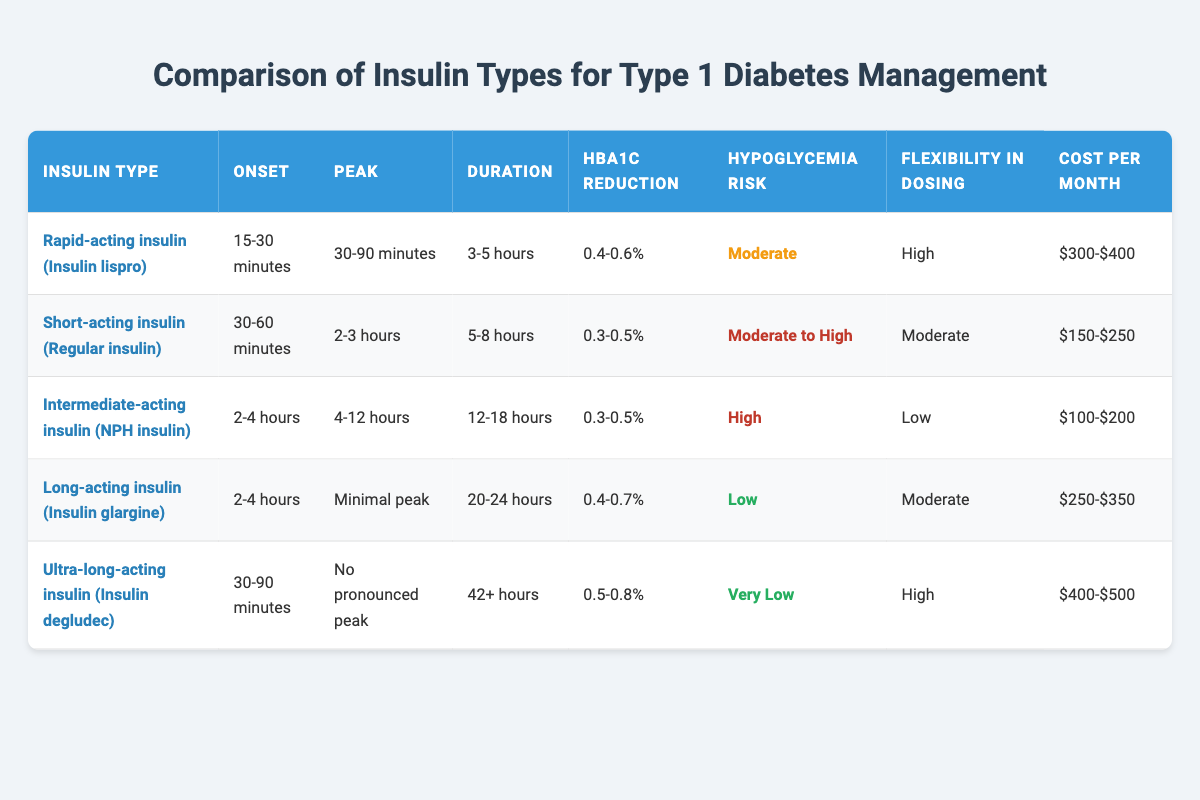What is the onset time for ultra-long-acting insulin? From the table, the onset time for ultra-long-acting insulin (Insulin degludec) is given as 30-90 minutes.
Answer: 30-90 minutes Which insulin type has the lowest hypoglycemia risk? The table indicates that ultra-long-acting insulin (Insulin degludec) has a hypoglycemia risk categorized as "Very Low," which is lower than all other insulin types listed.
Answer: Ultra-long-acting insulin (Insulin degludec) What is the difference in duration between intermediate-acting insulin and long-acting insulin? Intermediate-acting insulin (NPH insulin) has a duration of 12-18 hours, and long-acting insulin (Insulin glargine) has a duration of 20-24 hours. The difference is calculated as (20-18) hours to (24-12) hours, which leads to a duration difference of 2 to 6 hours.
Answer: 2 to 6 hours Is it true that all rapid-acting insulins have a peak time of less than 2 hours? From the table, rapid-acting insulin (Insulin lispro) has a peak time of 30-90 minutes, which is indeed less than 2 hours. This is confirmed as the only rapid-acting insulin type mentioned.
Answer: Yes Which insulin type offers the highest flexibility in dosing? The table lists both rapid-acting insulin (Insulin lispro) and ultra-long-acting insulin (Insulin degludec) as having high flexibility in dosing. Therefore, the answer can encompass both.
Answer: Rapid-acting insulin and Ultra-long-acting insulin What is the average HbA1c reduction of the short-acting and intermediate-acting insulins combined? Short-acting insulin (Regular insulin) has an HbA1c reduction of 0.3-0.5%, and intermediate-acting insulin (NPH insulin) also has a reduction of 0.3-0.5%. The average is calculated by adding the lower limits (0.3% + 0.3% = 0.6%), and the upper limits (0.5% + 0.5% = 1.0%), giving a range of (0.6%/2) to (1.0%/2), which results in an average reduction of 0.3% to 0.5%.
Answer: 0.3% to 0.5% Which insulin type has the highest monthly cost? From the table, ultra-long-acting insulin (Insulin degludec) has the highest cost per month, ranging from $400 to $500, compared to other insulin types.
Answer: Ultra-long-acting insulin (Insulin degludec) What percentage reduction does long-acting insulin provide compared to short-acting insulin? Long-acting insulin (Insulin glargine) offers an HbA1c reduction of 0.4-0.7%, while short-acting insulin (Regular insulin) offers a reduction of 0.3-0.5%. The minimum reduction difference is calculated as (0.4 - 0.5) = -0.1% and the maximum is (0.7 - 0.3) = 0.4%. Therefore, the overall percentage decrease ranges from -0.1% to 0.4%.
Answer: -0.1% to 0.4% 